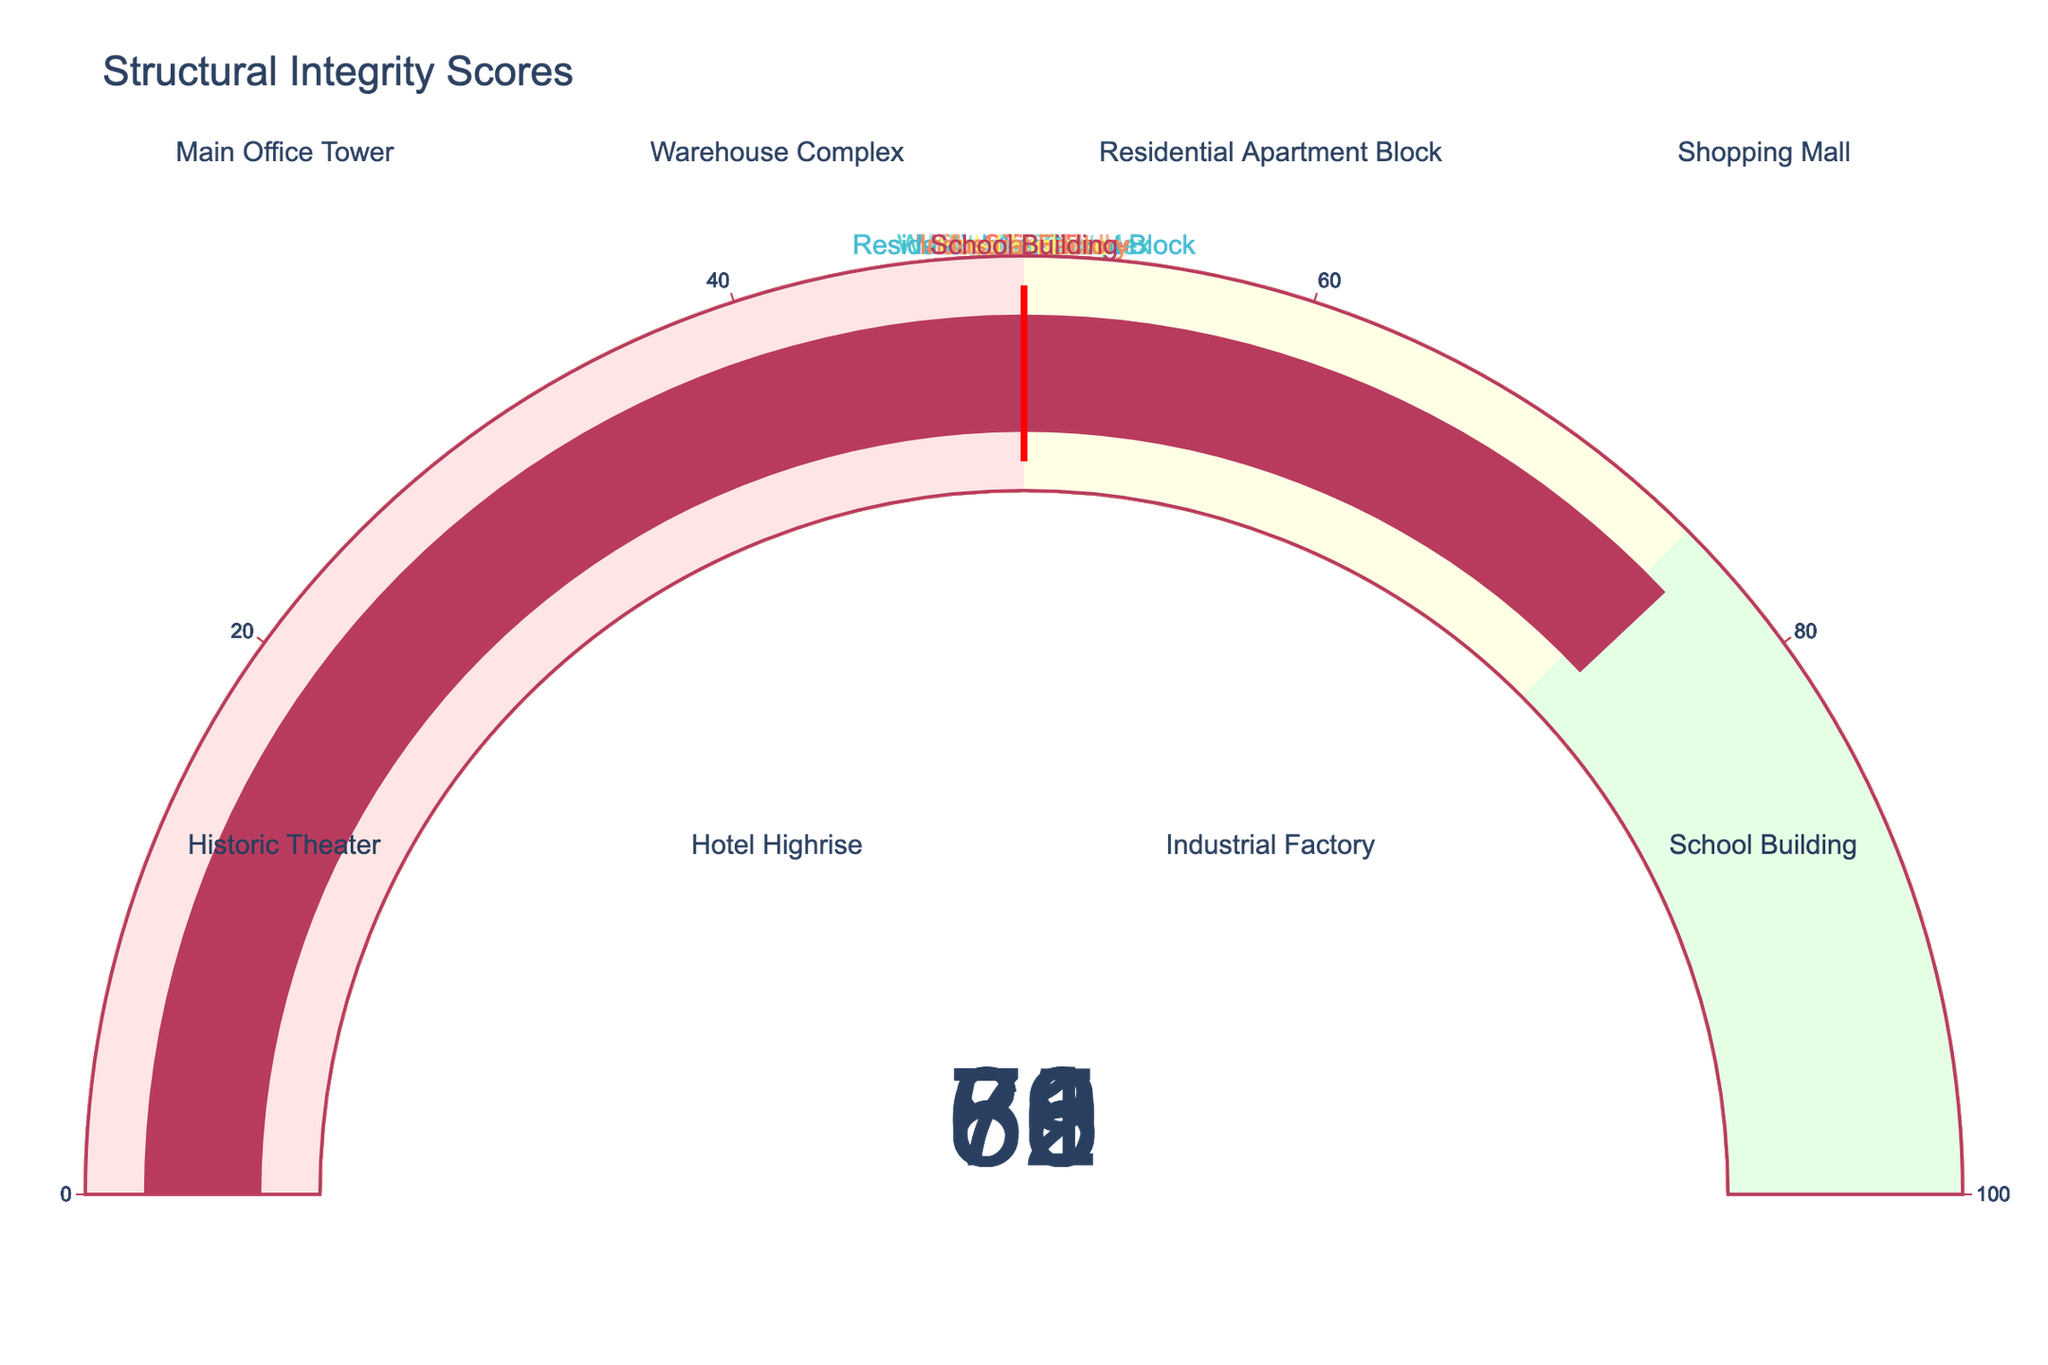What is the structural integrity score of the Residential Apartment Block? The gauge chart for the Residential Apartment Block has a score represented by the number in the center of the gauge.
Answer: 85 Which building has the lowest structural integrity score? By looking at the number displayed on each gauge, the Historic Theater has the lowest score.
Answer: Historic Theater Compare the structural integrity scores of the Main Office Tower and the Warehouse Complex. Which one is higher? Observing the numbers on the gauges for both buildings, the Main Office Tower has a score of 78 while the Warehouse Complex has a score of 62. Thus, the Main Office Tower has a higher score.
Answer: Main Office Tower What is the average structural integrity score of all the buildings shown? Add the scores of all buildings (78 + 62 + 85 + 71 + 59 + 83 + 68 + 76) and divide by the number of buildings (8) to find the average. The total sum is 582, so the average is 582 / 8 = 72.75.
Answer: 72.75 Which building's structural integrity score falls just above the threshold value of 50 but below 75? The buildings with scores between 51 and 74 are Warehouse Complex (62), Shopping Mall (71), and Industrial Factory (68).
Answer: Warehouse Complex, Shopping Mall, Industrial Factory For the buildings in the green range (scores between 75 and 100), what is their collective average score? The buildings in the green range are Main Office Tower (78), Residential Apartment Block (85), Hotel Highrise (83), and School Building (76). Sum their scores to get 322 and divide by 4 to find the average: 322 / 4 = 80.5.
Answer: 80.5 How many buildings fall within the yellow range of scores (between 50 and 75)? The gauge charts indicate that Warehouse Complex (62), Shopping Mall (71), and Industrial Factory (68) fall within this range. Therefore, there are 3 buildings in the yellow range.
Answer: 3 List the buildings with a structural integrity score above 80. The buildings with scores above 80 are the Residential Apartment Block (85) and Hotel Highrise (83).
Answer: Residential Apartment Block, Hotel Highrise 